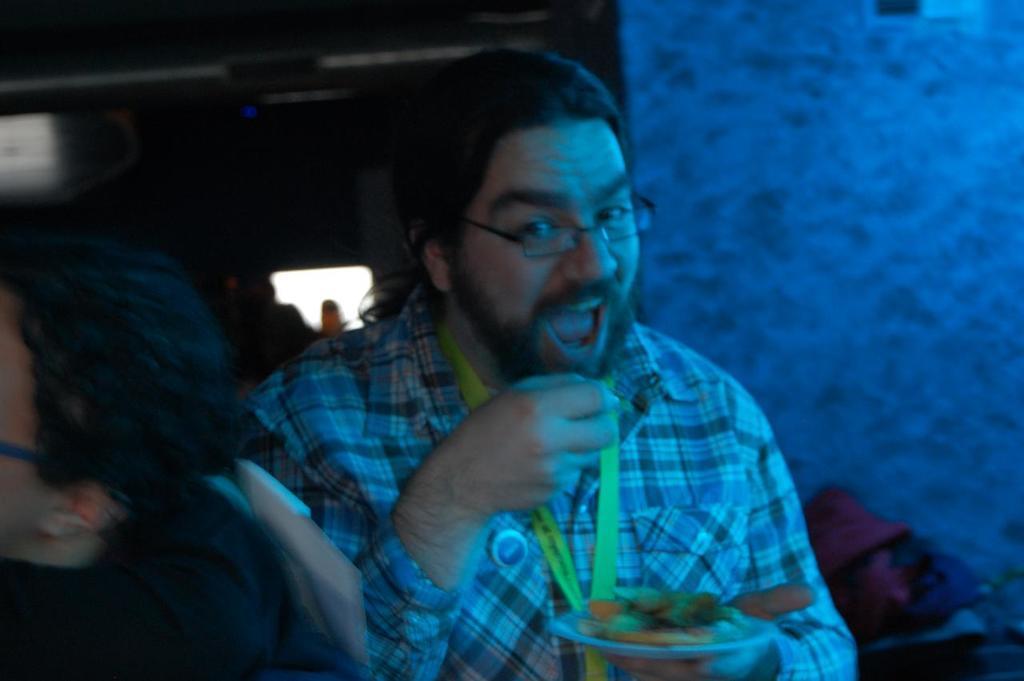Can you describe this image briefly? In this image a man is holding a plate of food. He is wearing a checked shirt. In the left there is another person. In the background there is wall and few other things are there. 